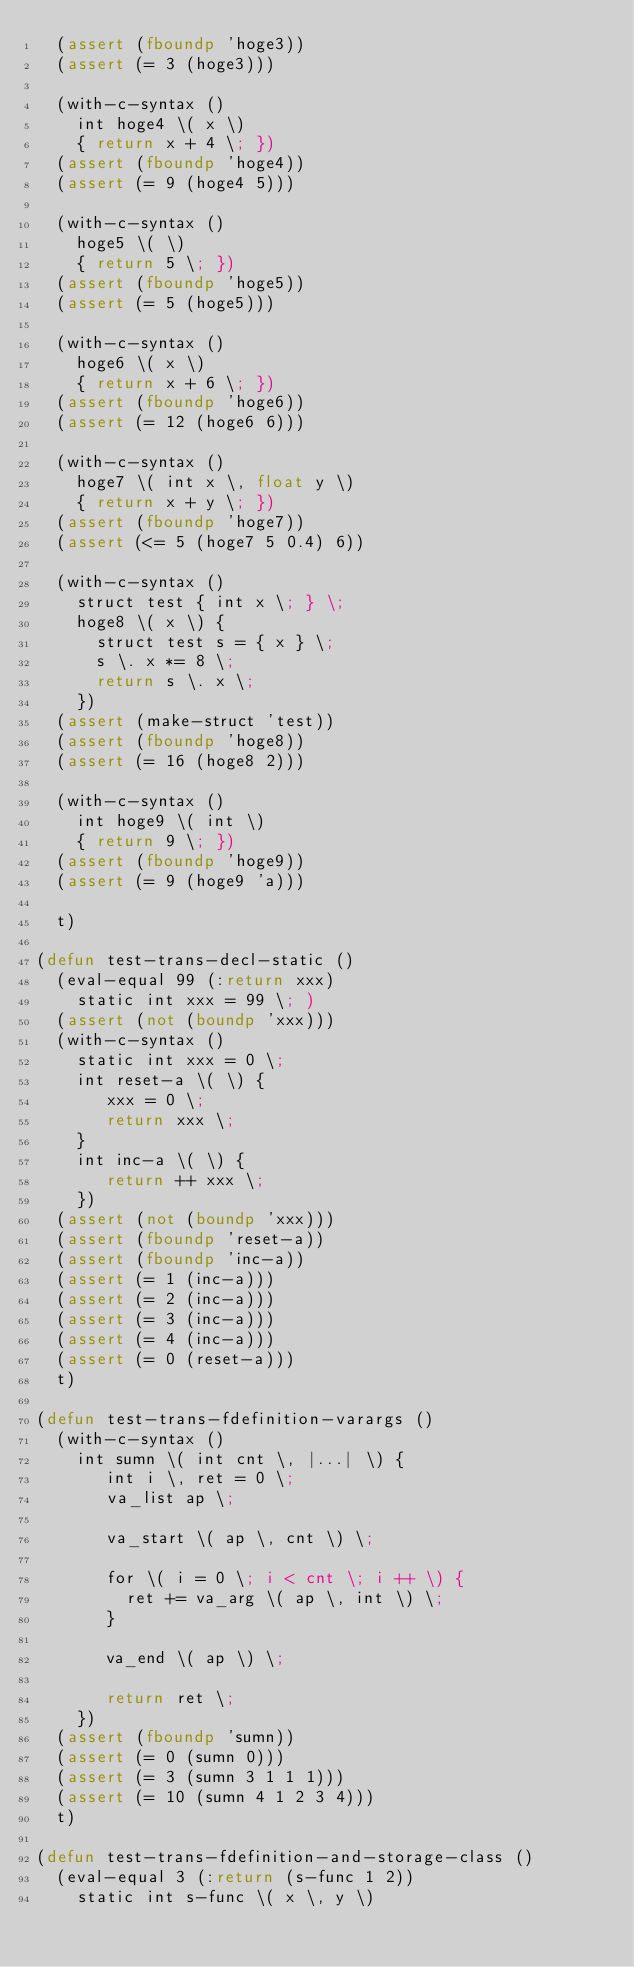Convert code to text. <code><loc_0><loc_0><loc_500><loc_500><_Lisp_>  (assert (fboundp 'hoge3))
  (assert (= 3 (hoge3)))

  (with-c-syntax ()
    int hoge4 \( x \)
    { return x + 4 \; })
  (assert (fboundp 'hoge4))
  (assert (= 9 (hoge4 5)))

  (with-c-syntax ()
    hoge5 \( \)
    { return 5 \; })
  (assert (fboundp 'hoge5))
  (assert (= 5 (hoge5)))

  (with-c-syntax ()
    hoge6 \( x \)
    { return x + 6 \; })
  (assert (fboundp 'hoge6))
  (assert (= 12 (hoge6 6)))

  (with-c-syntax ()
    hoge7 \( int x \, float y \)
    { return x + y \; })
  (assert (fboundp 'hoge7))
  (assert (<= 5 (hoge7 5 0.4) 6))

  (with-c-syntax ()
    struct test { int x \; } \;
    hoge8 \( x \) {
      struct test s = { x } \;
      s \. x *= 8 \;
      return s \. x \;
    })
  (assert (make-struct 'test))
  (assert (fboundp 'hoge8))
  (assert (= 16 (hoge8 2)))

  (with-c-syntax ()
    int hoge9 \( int \)
    { return 9 \; })
  (assert (fboundp 'hoge9))
  (assert (= 9 (hoge9 'a)))

  t)

(defun test-trans-decl-static ()
  (eval-equal 99 (:return xxx)
    static int xxx = 99 \; )
  (assert (not (boundp 'xxx)))
  (with-c-syntax ()
    static int xxx = 0 \;
    int reset-a \( \) {
       xxx = 0 \;
       return xxx \;
    }
    int inc-a \( \) {
       return ++ xxx \;
    })
  (assert (not (boundp 'xxx)))
  (assert (fboundp 'reset-a))
  (assert (fboundp 'inc-a))
  (assert (= 1 (inc-a)))
  (assert (= 2 (inc-a)))
  (assert (= 3 (inc-a)))
  (assert (= 4 (inc-a)))
  (assert (= 0 (reset-a)))
  t)

(defun test-trans-fdefinition-varargs ()
  (with-c-syntax ()
    int sumn \( int cnt \, |...| \) {
       int i \, ret = 0 \;
       va_list ap \;

       va_start \( ap \, cnt \) \;

       for \( i = 0 \; i < cnt \; i ++ \) {
         ret += va_arg \( ap \, int \) \;
       }

       va_end \( ap \) \;

       return ret \;
    })
  (assert (fboundp 'sumn))
  (assert (= 0 (sumn 0)))
  (assert (= 3 (sumn 3 1 1 1)))
  (assert (= 10 (sumn 4 1 2 3 4)))
  t)

(defun test-trans-fdefinition-and-storage-class ()
  (eval-equal 3 (:return (s-func 1 2))
    static int s-func \( x \, y \)</code> 